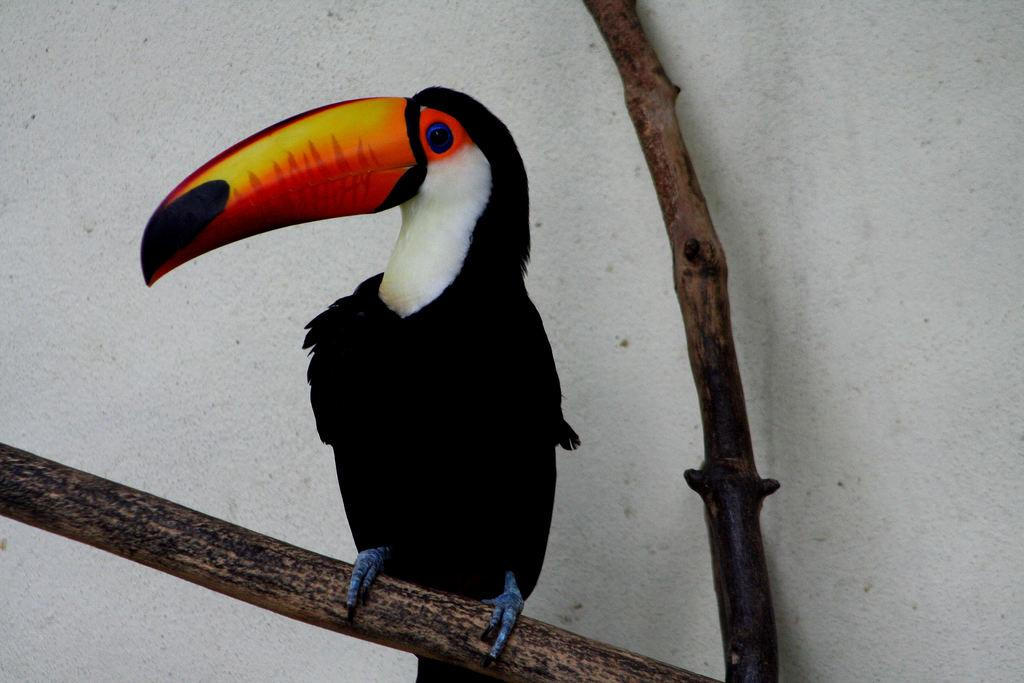What type of animal can be seen in the image? There is a bird in the image. Where is the bird located in the image? The bird is standing on a branch of a tree. Can you describe the position of the tree branch in the image? The tree branch is in the center of the image. How many eyes can be seen on the furniture in the image? There is no furniture present in the image, and therefore no eyes can be seen on it. 